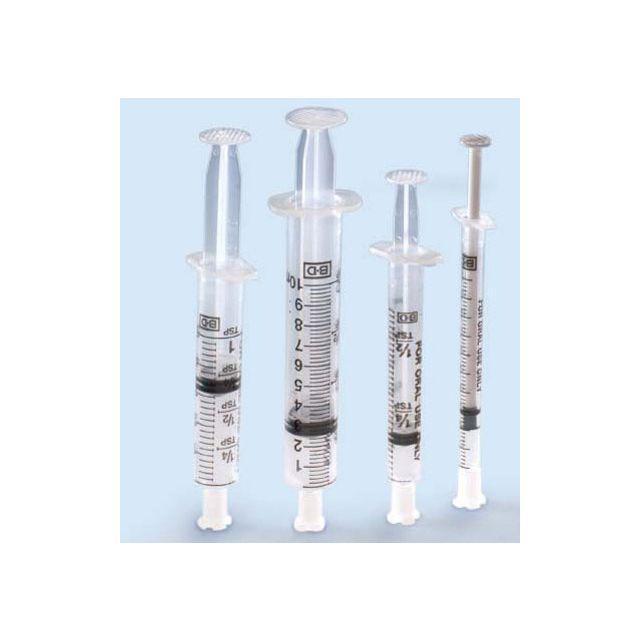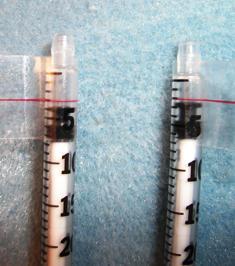The first image is the image on the left, the second image is the image on the right. Given the left and right images, does the statement "One of the syringes has a green tip." hold true? Answer yes or no. No. The first image is the image on the left, the second image is the image on the right. Considering the images on both sides, is "At least one photo contains a syringe with a green tip." valid? Answer yes or no. No. 